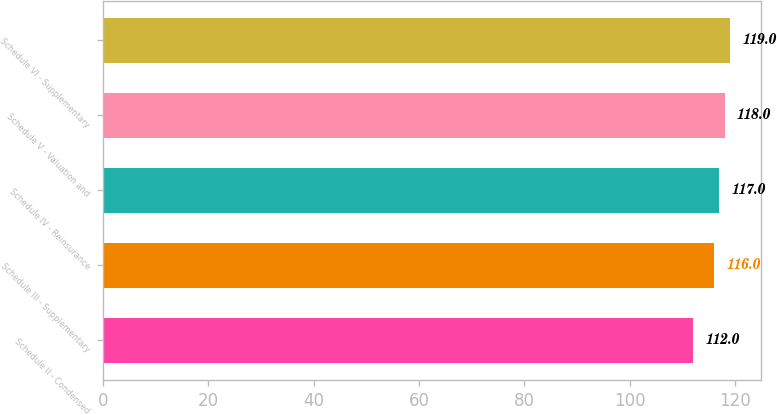Convert chart. <chart><loc_0><loc_0><loc_500><loc_500><bar_chart><fcel>Schedule II - Condensed<fcel>Schedule III - Supplementary<fcel>Schedule IV - Reinsurance<fcel>Schedule V - Valuation and<fcel>Schedule VI - Supplementary<nl><fcel>112<fcel>116<fcel>117<fcel>118<fcel>119<nl></chart> 